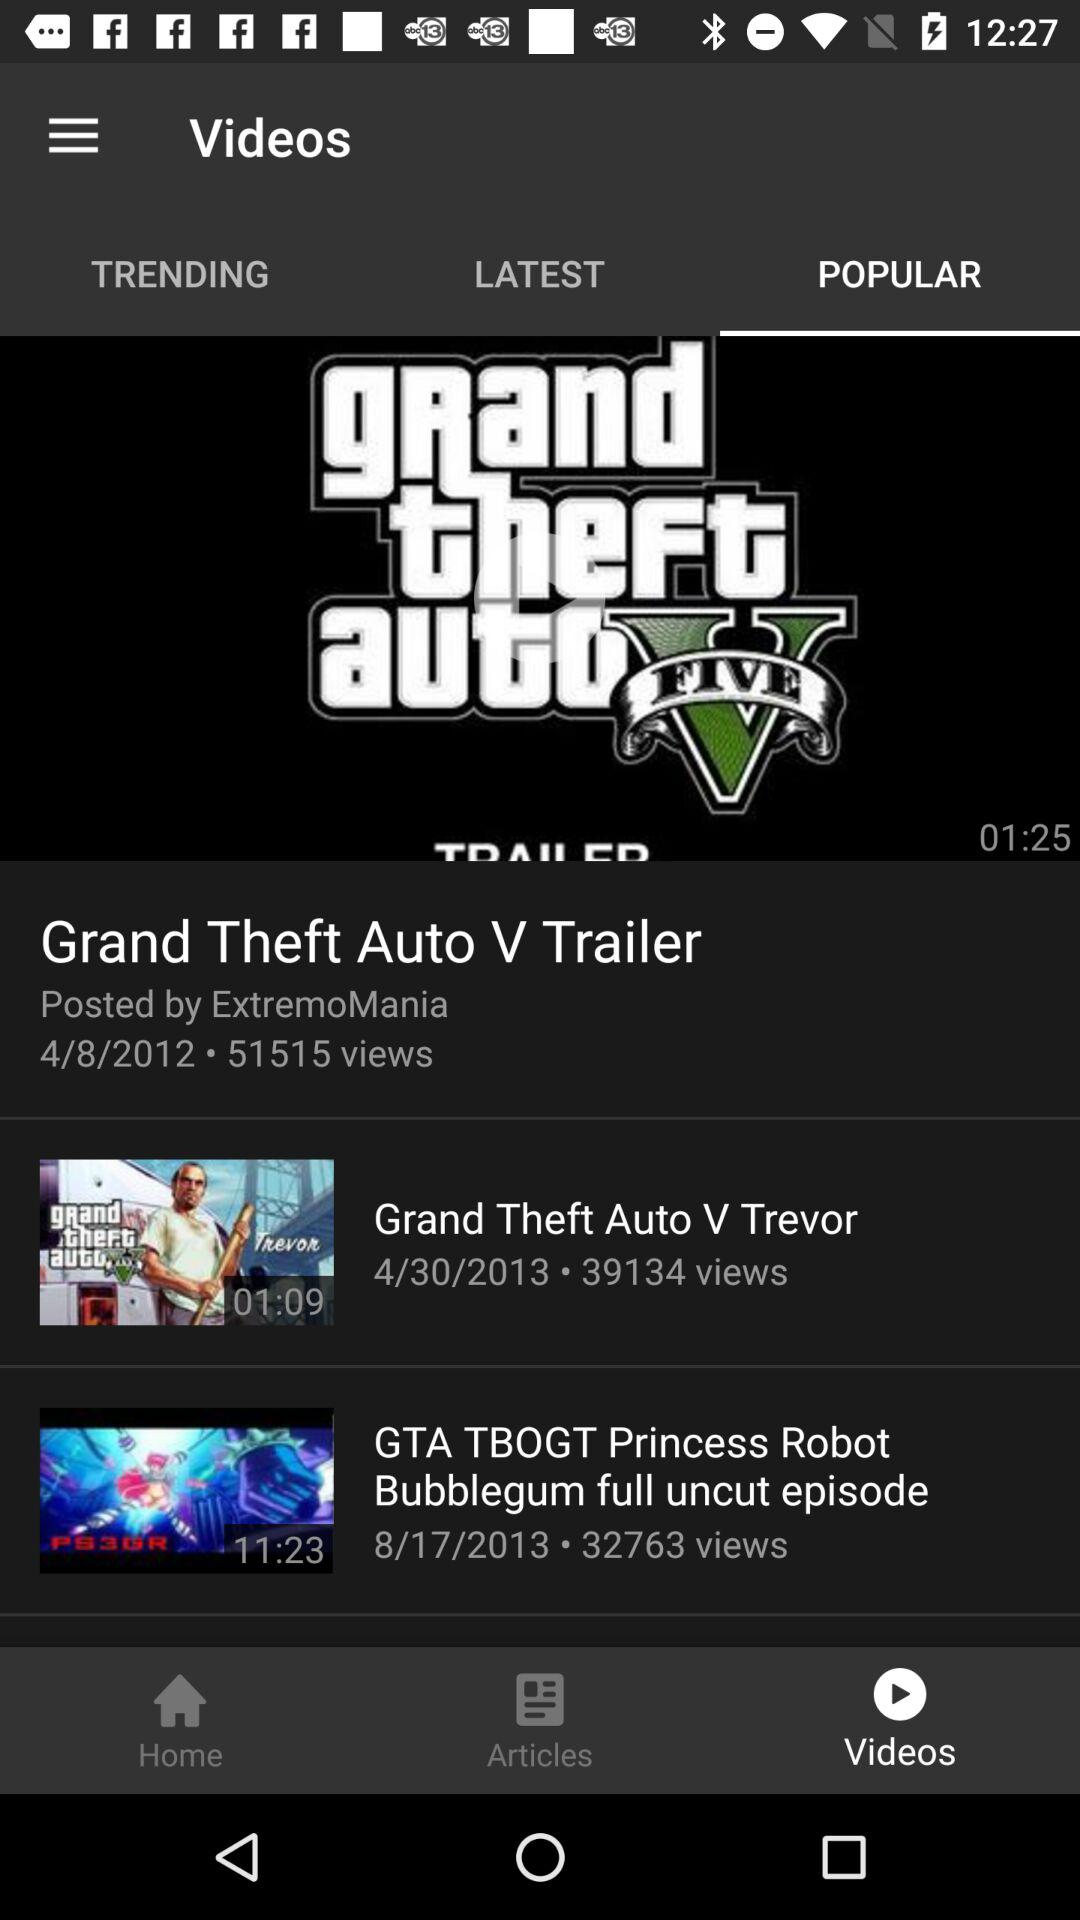What is the number of views of the "Grand Theft Auto V Trailer"? The number of views of the "Grand Theft Auto V Trailer" is 51515. 